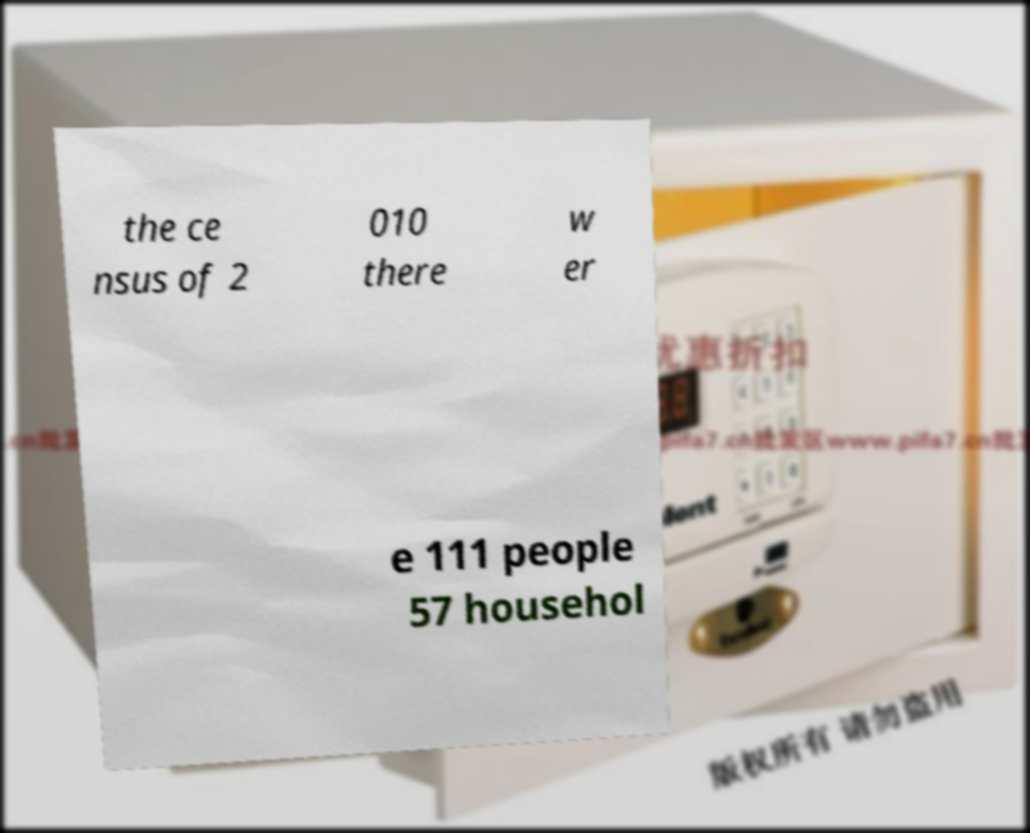For documentation purposes, I need the text within this image transcribed. Could you provide that? the ce nsus of 2 010 there w er e 111 people 57 househol 